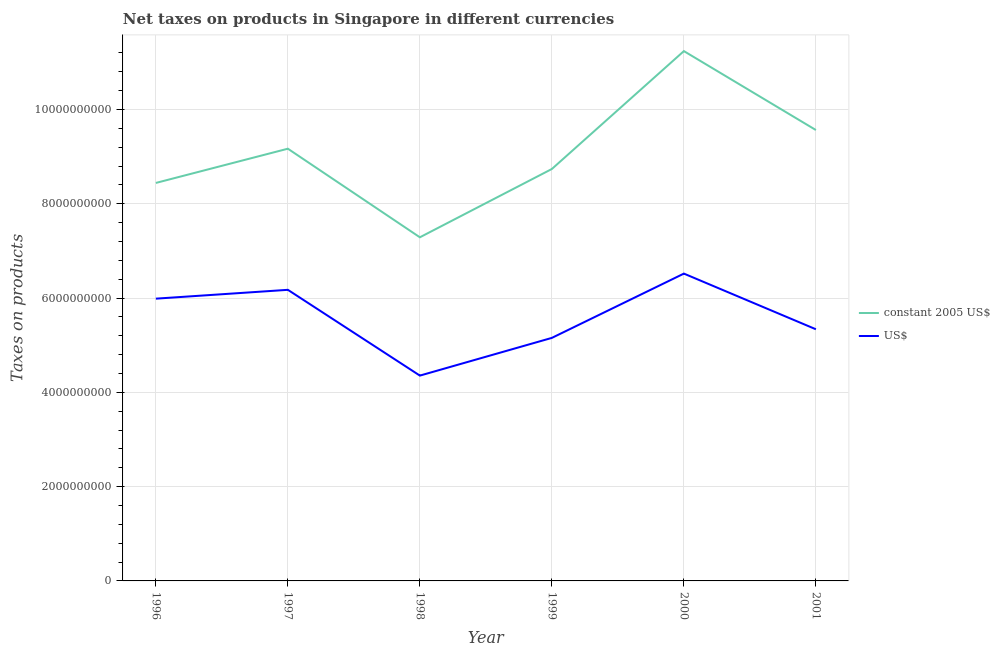How many different coloured lines are there?
Your response must be concise. 2. Does the line corresponding to net taxes in us$ intersect with the line corresponding to net taxes in constant 2005 us$?
Your answer should be compact. No. What is the net taxes in us$ in 2000?
Give a very brief answer. 6.52e+09. Across all years, what is the maximum net taxes in constant 2005 us$?
Ensure brevity in your answer.  1.12e+1. Across all years, what is the minimum net taxes in constant 2005 us$?
Offer a terse response. 7.29e+09. In which year was the net taxes in us$ maximum?
Offer a very short reply. 2000. In which year was the net taxes in constant 2005 us$ minimum?
Provide a succinct answer. 1998. What is the total net taxes in us$ in the graph?
Your response must be concise. 3.35e+1. What is the difference between the net taxes in us$ in 1996 and that in 2000?
Provide a short and direct response. -5.31e+08. What is the difference between the net taxes in us$ in 1997 and the net taxes in constant 2005 us$ in 1999?
Provide a short and direct response. -2.56e+09. What is the average net taxes in constant 2005 us$ per year?
Your answer should be compact. 9.07e+09. In the year 1997, what is the difference between the net taxes in constant 2005 us$ and net taxes in us$?
Your response must be concise. 2.99e+09. What is the ratio of the net taxes in us$ in 2000 to that in 2001?
Make the answer very short. 1.22. Is the difference between the net taxes in us$ in 1999 and 2000 greater than the difference between the net taxes in constant 2005 us$ in 1999 and 2000?
Ensure brevity in your answer.  Yes. What is the difference between the highest and the second highest net taxes in constant 2005 us$?
Offer a very short reply. 1.67e+09. What is the difference between the highest and the lowest net taxes in constant 2005 us$?
Offer a very short reply. 3.95e+09. Is the net taxes in us$ strictly greater than the net taxes in constant 2005 us$ over the years?
Ensure brevity in your answer.  No. How many lines are there?
Offer a terse response. 2. How many years are there in the graph?
Offer a very short reply. 6. What is the difference between two consecutive major ticks on the Y-axis?
Provide a short and direct response. 2.00e+09. Does the graph contain any zero values?
Provide a succinct answer. No. Does the graph contain grids?
Your answer should be compact. Yes. How are the legend labels stacked?
Your answer should be compact. Vertical. What is the title of the graph?
Provide a short and direct response. Net taxes on products in Singapore in different currencies. What is the label or title of the Y-axis?
Offer a terse response. Taxes on products. What is the Taxes on products of constant 2005 US$ in 1996?
Your response must be concise. 8.44e+09. What is the Taxes on products of US$ in 1996?
Keep it short and to the point. 5.99e+09. What is the Taxes on products of constant 2005 US$ in 1997?
Provide a short and direct response. 9.17e+09. What is the Taxes on products of US$ in 1997?
Make the answer very short. 6.17e+09. What is the Taxes on products in constant 2005 US$ in 1998?
Your answer should be very brief. 7.29e+09. What is the Taxes on products in US$ in 1998?
Your answer should be compact. 4.35e+09. What is the Taxes on products in constant 2005 US$ in 1999?
Give a very brief answer. 8.74e+09. What is the Taxes on products in US$ in 1999?
Offer a very short reply. 5.15e+09. What is the Taxes on products of constant 2005 US$ in 2000?
Ensure brevity in your answer.  1.12e+1. What is the Taxes on products of US$ in 2000?
Provide a short and direct response. 6.52e+09. What is the Taxes on products in constant 2005 US$ in 2001?
Give a very brief answer. 9.56e+09. What is the Taxes on products of US$ in 2001?
Keep it short and to the point. 5.34e+09. Across all years, what is the maximum Taxes on products of constant 2005 US$?
Your answer should be compact. 1.12e+1. Across all years, what is the maximum Taxes on products of US$?
Provide a short and direct response. 6.52e+09. Across all years, what is the minimum Taxes on products in constant 2005 US$?
Keep it short and to the point. 7.29e+09. Across all years, what is the minimum Taxes on products in US$?
Offer a very short reply. 4.35e+09. What is the total Taxes on products of constant 2005 US$ in the graph?
Offer a terse response. 5.44e+1. What is the total Taxes on products in US$ in the graph?
Provide a succinct answer. 3.35e+1. What is the difference between the Taxes on products of constant 2005 US$ in 1996 and that in 1997?
Make the answer very short. -7.26e+08. What is the difference between the Taxes on products in US$ in 1996 and that in 1997?
Your answer should be very brief. -1.87e+08. What is the difference between the Taxes on products in constant 2005 US$ in 1996 and that in 1998?
Provide a succinct answer. 1.15e+09. What is the difference between the Taxes on products of US$ in 1996 and that in 1998?
Provide a short and direct response. 1.63e+09. What is the difference between the Taxes on products of constant 2005 US$ in 1996 and that in 1999?
Your response must be concise. -2.96e+08. What is the difference between the Taxes on products in US$ in 1996 and that in 1999?
Ensure brevity in your answer.  8.32e+08. What is the difference between the Taxes on products of constant 2005 US$ in 1996 and that in 2000?
Your answer should be very brief. -2.80e+09. What is the difference between the Taxes on products in US$ in 1996 and that in 2000?
Your answer should be compact. -5.31e+08. What is the difference between the Taxes on products of constant 2005 US$ in 1996 and that in 2001?
Your answer should be very brief. -1.12e+09. What is the difference between the Taxes on products in US$ in 1996 and that in 2001?
Give a very brief answer. 6.49e+08. What is the difference between the Taxes on products in constant 2005 US$ in 1997 and that in 1998?
Give a very brief answer. 1.88e+09. What is the difference between the Taxes on products of US$ in 1997 and that in 1998?
Give a very brief answer. 1.82e+09. What is the difference between the Taxes on products in constant 2005 US$ in 1997 and that in 1999?
Your response must be concise. 4.30e+08. What is the difference between the Taxes on products of US$ in 1997 and that in 1999?
Ensure brevity in your answer.  1.02e+09. What is the difference between the Taxes on products of constant 2005 US$ in 1997 and that in 2000?
Your answer should be very brief. -2.07e+09. What is the difference between the Taxes on products of US$ in 1997 and that in 2000?
Offer a terse response. -3.44e+08. What is the difference between the Taxes on products in constant 2005 US$ in 1997 and that in 2001?
Ensure brevity in your answer.  -3.96e+08. What is the difference between the Taxes on products of US$ in 1997 and that in 2001?
Offer a very short reply. 8.37e+08. What is the difference between the Taxes on products in constant 2005 US$ in 1998 and that in 1999?
Keep it short and to the point. -1.45e+09. What is the difference between the Taxes on products of US$ in 1998 and that in 1999?
Your answer should be compact. -8.00e+08. What is the difference between the Taxes on products of constant 2005 US$ in 1998 and that in 2000?
Keep it short and to the point. -3.95e+09. What is the difference between the Taxes on products in US$ in 1998 and that in 2000?
Offer a terse response. -2.16e+09. What is the difference between the Taxes on products of constant 2005 US$ in 1998 and that in 2001?
Give a very brief answer. -2.28e+09. What is the difference between the Taxes on products of US$ in 1998 and that in 2001?
Offer a very short reply. -9.83e+08. What is the difference between the Taxes on products of constant 2005 US$ in 1999 and that in 2000?
Ensure brevity in your answer.  -2.50e+09. What is the difference between the Taxes on products of US$ in 1999 and that in 2000?
Ensure brevity in your answer.  -1.36e+09. What is the difference between the Taxes on products in constant 2005 US$ in 1999 and that in 2001?
Make the answer very short. -8.26e+08. What is the difference between the Taxes on products in US$ in 1999 and that in 2001?
Your answer should be very brief. -1.83e+08. What is the difference between the Taxes on products in constant 2005 US$ in 2000 and that in 2001?
Ensure brevity in your answer.  1.67e+09. What is the difference between the Taxes on products of US$ in 2000 and that in 2001?
Offer a very short reply. 1.18e+09. What is the difference between the Taxes on products of constant 2005 US$ in 1996 and the Taxes on products of US$ in 1997?
Ensure brevity in your answer.  2.27e+09. What is the difference between the Taxes on products in constant 2005 US$ in 1996 and the Taxes on products in US$ in 1998?
Keep it short and to the point. 4.09e+09. What is the difference between the Taxes on products in constant 2005 US$ in 1996 and the Taxes on products in US$ in 1999?
Your answer should be compact. 3.29e+09. What is the difference between the Taxes on products of constant 2005 US$ in 1996 and the Taxes on products of US$ in 2000?
Provide a short and direct response. 1.92e+09. What is the difference between the Taxes on products in constant 2005 US$ in 1996 and the Taxes on products in US$ in 2001?
Provide a short and direct response. 3.10e+09. What is the difference between the Taxes on products in constant 2005 US$ in 1997 and the Taxes on products in US$ in 1998?
Give a very brief answer. 4.81e+09. What is the difference between the Taxes on products in constant 2005 US$ in 1997 and the Taxes on products in US$ in 1999?
Provide a succinct answer. 4.01e+09. What is the difference between the Taxes on products in constant 2005 US$ in 1997 and the Taxes on products in US$ in 2000?
Your answer should be compact. 2.65e+09. What is the difference between the Taxes on products in constant 2005 US$ in 1997 and the Taxes on products in US$ in 2001?
Keep it short and to the point. 3.83e+09. What is the difference between the Taxes on products in constant 2005 US$ in 1998 and the Taxes on products in US$ in 1999?
Offer a terse response. 2.13e+09. What is the difference between the Taxes on products of constant 2005 US$ in 1998 and the Taxes on products of US$ in 2000?
Ensure brevity in your answer.  7.70e+08. What is the difference between the Taxes on products in constant 2005 US$ in 1998 and the Taxes on products in US$ in 2001?
Offer a very short reply. 1.95e+09. What is the difference between the Taxes on products in constant 2005 US$ in 1999 and the Taxes on products in US$ in 2000?
Offer a terse response. 2.22e+09. What is the difference between the Taxes on products of constant 2005 US$ in 1999 and the Taxes on products of US$ in 2001?
Give a very brief answer. 3.40e+09. What is the difference between the Taxes on products in constant 2005 US$ in 2000 and the Taxes on products in US$ in 2001?
Provide a succinct answer. 5.90e+09. What is the average Taxes on products of constant 2005 US$ per year?
Provide a succinct answer. 9.07e+09. What is the average Taxes on products in US$ per year?
Keep it short and to the point. 5.59e+09. In the year 1996, what is the difference between the Taxes on products of constant 2005 US$ and Taxes on products of US$?
Offer a very short reply. 2.45e+09. In the year 1997, what is the difference between the Taxes on products of constant 2005 US$ and Taxes on products of US$?
Offer a terse response. 2.99e+09. In the year 1998, what is the difference between the Taxes on products in constant 2005 US$ and Taxes on products in US$?
Ensure brevity in your answer.  2.93e+09. In the year 1999, what is the difference between the Taxes on products in constant 2005 US$ and Taxes on products in US$?
Offer a terse response. 3.58e+09. In the year 2000, what is the difference between the Taxes on products in constant 2005 US$ and Taxes on products in US$?
Offer a terse response. 4.72e+09. In the year 2001, what is the difference between the Taxes on products in constant 2005 US$ and Taxes on products in US$?
Give a very brief answer. 4.23e+09. What is the ratio of the Taxes on products in constant 2005 US$ in 1996 to that in 1997?
Your response must be concise. 0.92. What is the ratio of the Taxes on products in US$ in 1996 to that in 1997?
Give a very brief answer. 0.97. What is the ratio of the Taxes on products of constant 2005 US$ in 1996 to that in 1998?
Offer a very short reply. 1.16. What is the ratio of the Taxes on products in US$ in 1996 to that in 1998?
Provide a succinct answer. 1.37. What is the ratio of the Taxes on products of constant 2005 US$ in 1996 to that in 1999?
Your answer should be compact. 0.97. What is the ratio of the Taxes on products of US$ in 1996 to that in 1999?
Make the answer very short. 1.16. What is the ratio of the Taxes on products of constant 2005 US$ in 1996 to that in 2000?
Your answer should be very brief. 0.75. What is the ratio of the Taxes on products in US$ in 1996 to that in 2000?
Give a very brief answer. 0.92. What is the ratio of the Taxes on products of constant 2005 US$ in 1996 to that in 2001?
Keep it short and to the point. 0.88. What is the ratio of the Taxes on products in US$ in 1996 to that in 2001?
Give a very brief answer. 1.12. What is the ratio of the Taxes on products in constant 2005 US$ in 1997 to that in 1998?
Offer a terse response. 1.26. What is the ratio of the Taxes on products in US$ in 1997 to that in 1998?
Give a very brief answer. 1.42. What is the ratio of the Taxes on products in constant 2005 US$ in 1997 to that in 1999?
Make the answer very short. 1.05. What is the ratio of the Taxes on products of US$ in 1997 to that in 1999?
Offer a terse response. 1.2. What is the ratio of the Taxes on products of constant 2005 US$ in 1997 to that in 2000?
Give a very brief answer. 0.82. What is the ratio of the Taxes on products of US$ in 1997 to that in 2000?
Your answer should be very brief. 0.95. What is the ratio of the Taxes on products of constant 2005 US$ in 1997 to that in 2001?
Give a very brief answer. 0.96. What is the ratio of the Taxes on products of US$ in 1997 to that in 2001?
Ensure brevity in your answer.  1.16. What is the ratio of the Taxes on products of constant 2005 US$ in 1998 to that in 1999?
Give a very brief answer. 0.83. What is the ratio of the Taxes on products of US$ in 1998 to that in 1999?
Offer a terse response. 0.84. What is the ratio of the Taxes on products of constant 2005 US$ in 1998 to that in 2000?
Provide a short and direct response. 0.65. What is the ratio of the Taxes on products of US$ in 1998 to that in 2000?
Make the answer very short. 0.67. What is the ratio of the Taxes on products in constant 2005 US$ in 1998 to that in 2001?
Your answer should be compact. 0.76. What is the ratio of the Taxes on products in US$ in 1998 to that in 2001?
Offer a very short reply. 0.82. What is the ratio of the Taxes on products of constant 2005 US$ in 1999 to that in 2000?
Your answer should be very brief. 0.78. What is the ratio of the Taxes on products in US$ in 1999 to that in 2000?
Provide a succinct answer. 0.79. What is the ratio of the Taxes on products in constant 2005 US$ in 1999 to that in 2001?
Ensure brevity in your answer.  0.91. What is the ratio of the Taxes on products in US$ in 1999 to that in 2001?
Your response must be concise. 0.97. What is the ratio of the Taxes on products of constant 2005 US$ in 2000 to that in 2001?
Give a very brief answer. 1.18. What is the ratio of the Taxes on products in US$ in 2000 to that in 2001?
Give a very brief answer. 1.22. What is the difference between the highest and the second highest Taxes on products of constant 2005 US$?
Your answer should be compact. 1.67e+09. What is the difference between the highest and the second highest Taxes on products in US$?
Ensure brevity in your answer.  3.44e+08. What is the difference between the highest and the lowest Taxes on products of constant 2005 US$?
Ensure brevity in your answer.  3.95e+09. What is the difference between the highest and the lowest Taxes on products of US$?
Keep it short and to the point. 2.16e+09. 